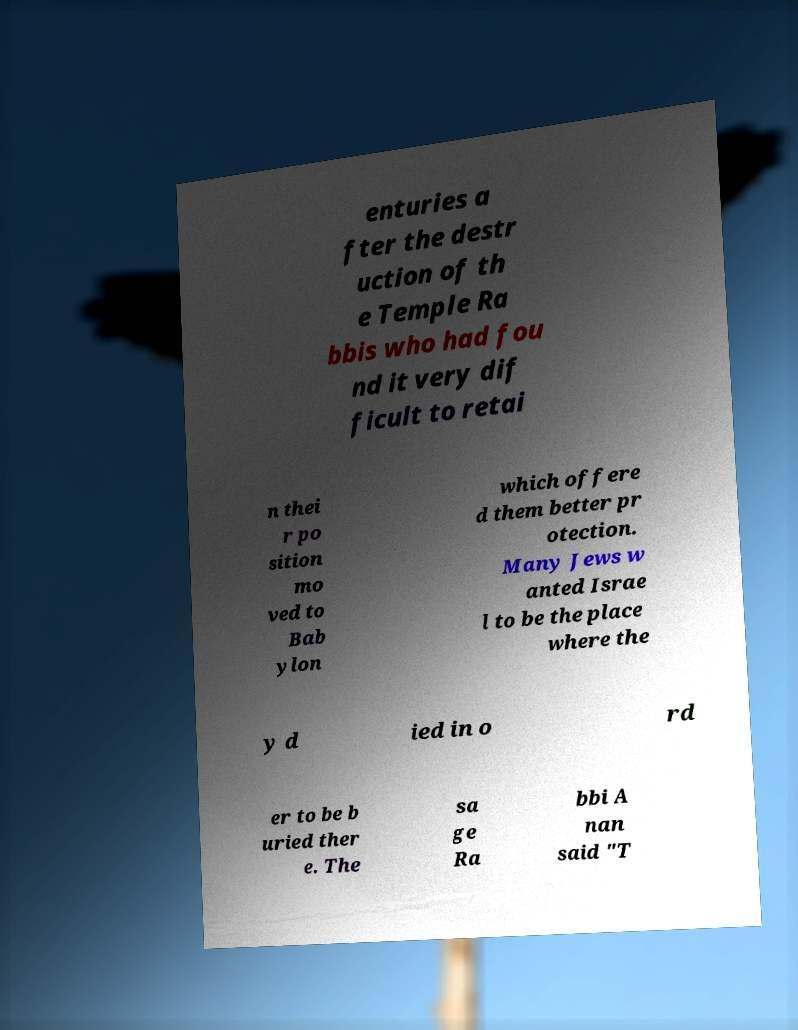There's text embedded in this image that I need extracted. Can you transcribe it verbatim? enturies a fter the destr uction of th e Temple Ra bbis who had fou nd it very dif ficult to retai n thei r po sition mo ved to Bab ylon which offere d them better pr otection. Many Jews w anted Israe l to be the place where the y d ied in o rd er to be b uried ther e. The sa ge Ra bbi A nan said "T 